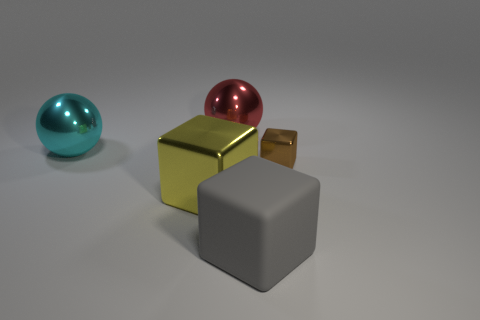Add 4 green shiny spheres. How many objects exist? 9 Subtract all tiny brown cubes. How many cubes are left? 2 Subtract all balls. How many objects are left? 3 Subtract all yellow shiny things. Subtract all big yellow metal blocks. How many objects are left? 3 Add 4 blocks. How many blocks are left? 7 Add 3 big gray blocks. How many big gray blocks exist? 4 Subtract all red spheres. How many spheres are left? 1 Subtract 1 red spheres. How many objects are left? 4 Subtract 2 cubes. How many cubes are left? 1 Subtract all green cubes. Subtract all yellow spheres. How many cubes are left? 3 